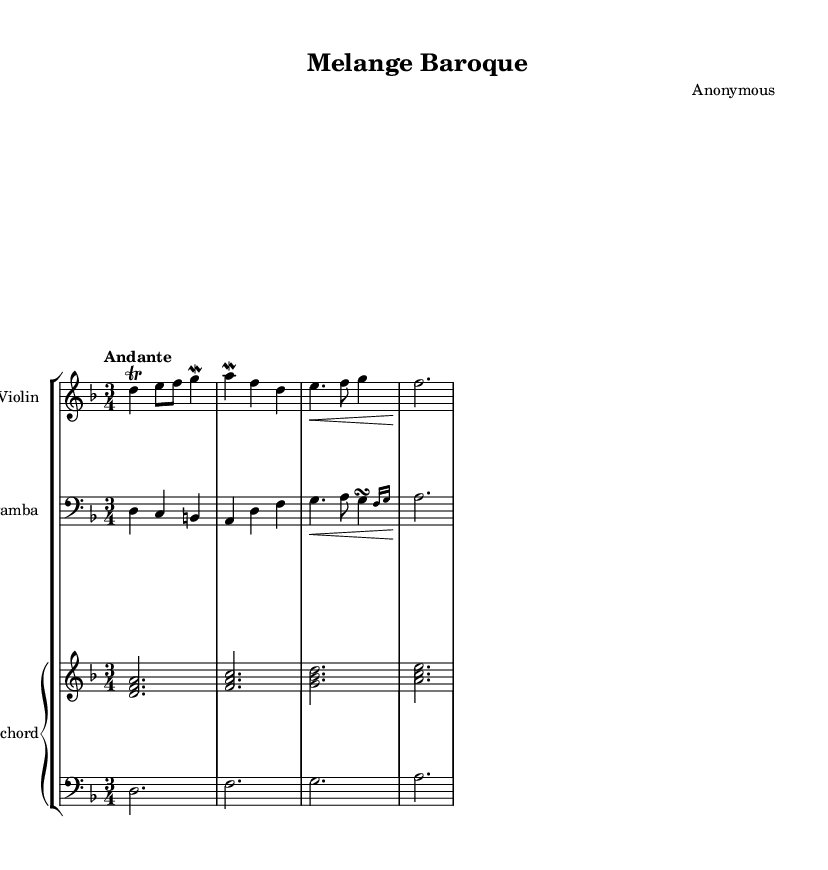What is the key signature of this music? The key signature is D minor, which has one flat (B flat). This is determined by the key indicated at the beginning of the staff.
Answer: D minor What is the time signature of this music? The time signature is 3/4, meaning there are three beats per measure and the quarter note receives one beat. This can be seen in the time signature marking at the beginning of the sheet music.
Answer: 3/4 What is the tempo marking for this piece? The tempo marking is "Andante," which suggests a moderately slow pace. This is indicated in the tempo line at the beginning of the score.
Answer: Andante How many measures are present in the violin part? There are four measures in the violin part. By counting the groupings of the bars on the staff, we can confirm this.
Answer: 4 Which instruments are included in this chamber music piece? The instruments in this piece are Violin, Viola da gamba, and Harpsichord. This is evident from the labels written at the start of each staff.
Answer: Violin, Viola da gamba, Harpsichord What ornament is predominantly used in the violin part? The predominant ornament in the violin part is the trill. This is identified by the notation that represents a rapid alternation between two adjacent notes.
Answer: Trill What is the dynamic marking for the viola da gamba part at the end of the measure? The dynamic marking is a hairpin crescendo, indicated by the symbol that gradually increases in volume. This can be found at the start of the third measure of the viola part.
Answer: None 